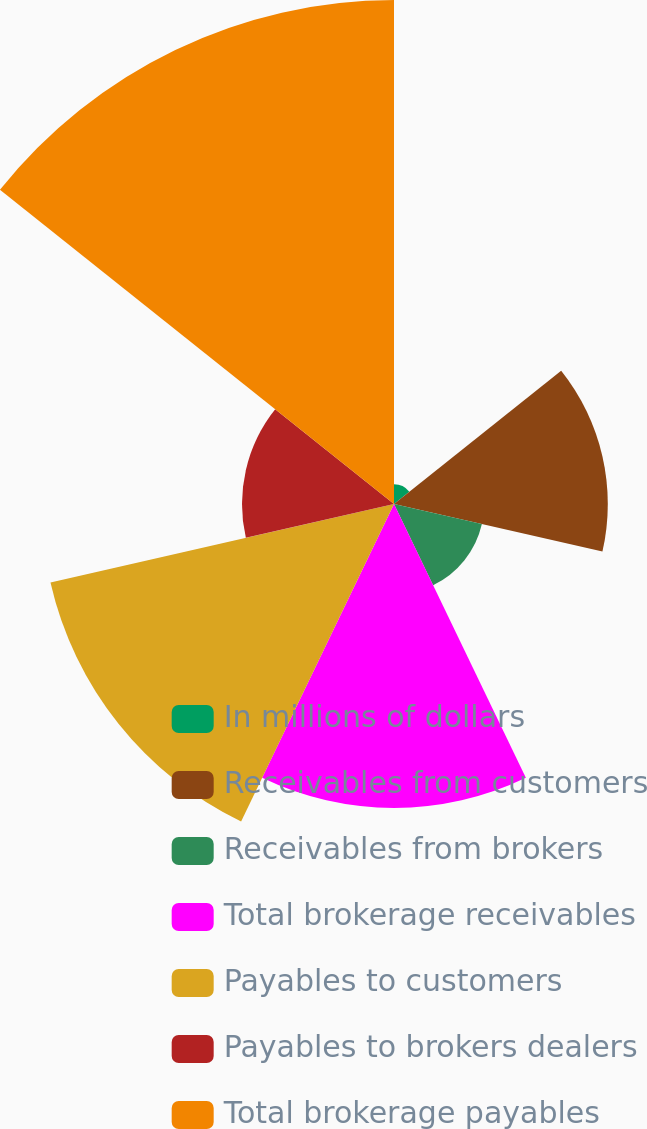Convert chart to OTSL. <chart><loc_0><loc_0><loc_500><loc_500><pie_chart><fcel>In millions of dollars<fcel>Receivables from customers<fcel>Receivables from brokers<fcel>Total brokerage receivables<fcel>Payables to customers<fcel>Payables to brokers dealers<fcel>Total brokerage payables<nl><fcel>1.2%<fcel>13.07%<fcel>5.51%<fcel>18.58%<fcel>21.54%<fcel>9.29%<fcel>30.81%<nl></chart> 